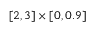Convert formula to latex. <formula><loc_0><loc_0><loc_500><loc_500>[ 2 , 3 ] \times [ 0 , 0 . 9 ]</formula> 